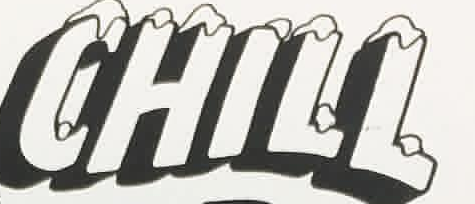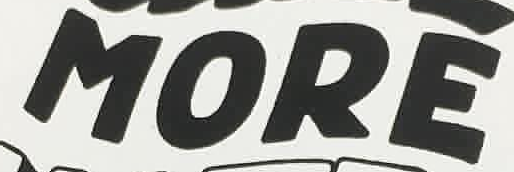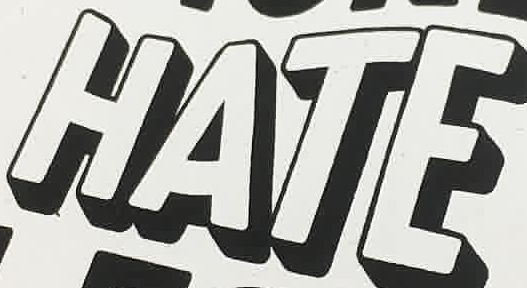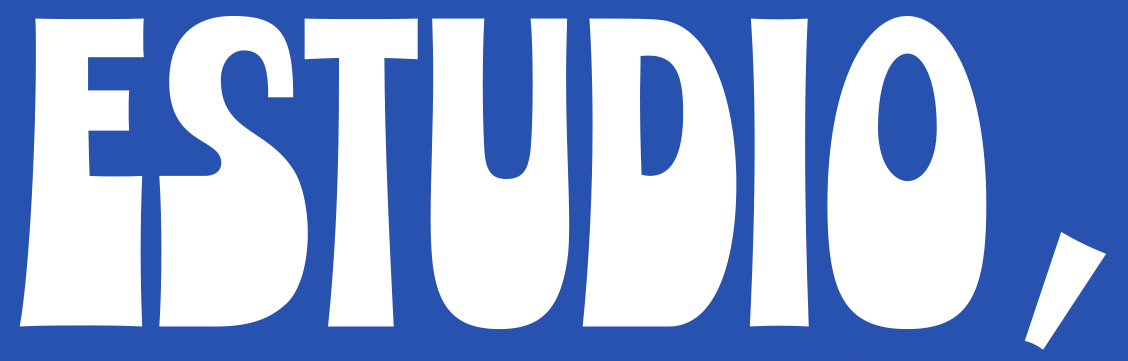What text appears in these images from left to right, separated by a semicolon? CHILL; MORE; HATE; ESTUDIO, 